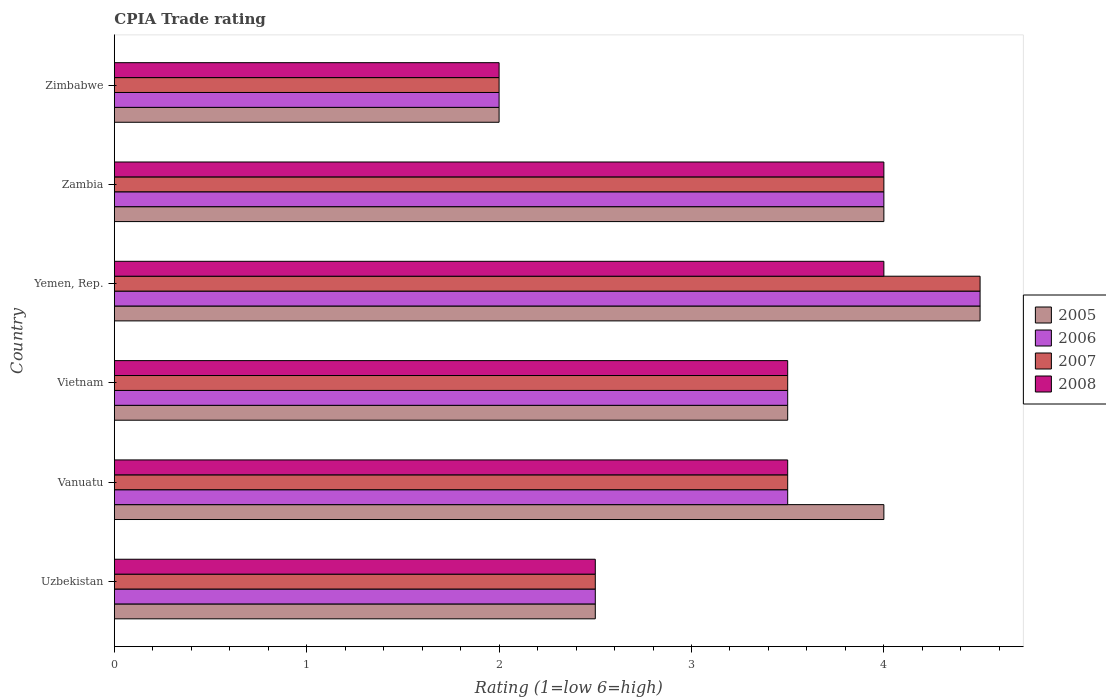How many different coloured bars are there?
Keep it short and to the point. 4. Are the number of bars on each tick of the Y-axis equal?
Offer a terse response. Yes. How many bars are there on the 5th tick from the top?
Give a very brief answer. 4. What is the label of the 2nd group of bars from the top?
Your answer should be very brief. Zambia. Across all countries, what is the minimum CPIA rating in 2008?
Your answer should be very brief. 2. In which country was the CPIA rating in 2007 maximum?
Provide a succinct answer. Yemen, Rep. In which country was the CPIA rating in 2006 minimum?
Provide a short and direct response. Zimbabwe. What is the average CPIA rating in 2006 per country?
Keep it short and to the point. 3.33. What is the difference between the CPIA rating in 2008 and CPIA rating in 2006 in Yemen, Rep.?
Make the answer very short. -0.5. In how many countries, is the CPIA rating in 2005 greater than 2.8 ?
Ensure brevity in your answer.  4. Is the CPIA rating in 2006 in Uzbekistan less than that in Vietnam?
Ensure brevity in your answer.  Yes. What is the difference between the highest and the second highest CPIA rating in 2006?
Your answer should be very brief. 0.5. Is the sum of the CPIA rating in 2005 in Yemen, Rep. and Zambia greater than the maximum CPIA rating in 2008 across all countries?
Make the answer very short. Yes. Is it the case that in every country, the sum of the CPIA rating in 2006 and CPIA rating in 2007 is greater than the sum of CPIA rating in 2008 and CPIA rating in 2005?
Give a very brief answer. No. What does the 3rd bar from the top in Zambia represents?
Your answer should be compact. 2006. Is it the case that in every country, the sum of the CPIA rating in 2007 and CPIA rating in 2006 is greater than the CPIA rating in 2005?
Your response must be concise. Yes. What is the difference between two consecutive major ticks on the X-axis?
Ensure brevity in your answer.  1. Are the values on the major ticks of X-axis written in scientific E-notation?
Keep it short and to the point. No. How many legend labels are there?
Offer a very short reply. 4. What is the title of the graph?
Offer a very short reply. CPIA Trade rating. What is the label or title of the Y-axis?
Provide a succinct answer. Country. What is the Rating (1=low 6=high) of 2006 in Uzbekistan?
Provide a short and direct response. 2.5. What is the Rating (1=low 6=high) of 2008 in Uzbekistan?
Offer a terse response. 2.5. What is the Rating (1=low 6=high) of 2005 in Vanuatu?
Your answer should be compact. 4. What is the Rating (1=low 6=high) of 2006 in Vanuatu?
Keep it short and to the point. 3.5. What is the Rating (1=low 6=high) of 2008 in Vanuatu?
Ensure brevity in your answer.  3.5. What is the Rating (1=low 6=high) in 2005 in Vietnam?
Offer a very short reply. 3.5. What is the Rating (1=low 6=high) in 2006 in Vietnam?
Your answer should be very brief. 3.5. What is the Rating (1=low 6=high) in 2007 in Vietnam?
Ensure brevity in your answer.  3.5. What is the Rating (1=low 6=high) of 2008 in Vietnam?
Keep it short and to the point. 3.5. What is the Rating (1=low 6=high) in 2005 in Yemen, Rep.?
Offer a terse response. 4.5. What is the Rating (1=low 6=high) in 2007 in Yemen, Rep.?
Make the answer very short. 4.5. What is the Rating (1=low 6=high) in 2008 in Yemen, Rep.?
Your response must be concise. 4. What is the Rating (1=low 6=high) of 2005 in Zambia?
Ensure brevity in your answer.  4. What is the Rating (1=low 6=high) in 2006 in Zambia?
Ensure brevity in your answer.  4. What is the Rating (1=low 6=high) of 2008 in Zambia?
Provide a succinct answer. 4. What is the Rating (1=low 6=high) in 2005 in Zimbabwe?
Ensure brevity in your answer.  2. What is the Rating (1=low 6=high) of 2006 in Zimbabwe?
Your answer should be compact. 2. What is the Rating (1=low 6=high) of 2007 in Zimbabwe?
Your answer should be very brief. 2. Across all countries, what is the maximum Rating (1=low 6=high) in 2006?
Your answer should be compact. 4.5. Across all countries, what is the maximum Rating (1=low 6=high) in 2007?
Your answer should be very brief. 4.5. Across all countries, what is the maximum Rating (1=low 6=high) of 2008?
Your response must be concise. 4. Across all countries, what is the minimum Rating (1=low 6=high) of 2006?
Give a very brief answer. 2. What is the total Rating (1=low 6=high) of 2006 in the graph?
Make the answer very short. 20. What is the total Rating (1=low 6=high) of 2008 in the graph?
Provide a succinct answer. 19.5. What is the difference between the Rating (1=low 6=high) of 2005 in Uzbekistan and that in Vanuatu?
Offer a terse response. -1.5. What is the difference between the Rating (1=low 6=high) in 2008 in Uzbekistan and that in Vanuatu?
Offer a very short reply. -1. What is the difference between the Rating (1=low 6=high) in 2006 in Uzbekistan and that in Vietnam?
Give a very brief answer. -1. What is the difference between the Rating (1=low 6=high) in 2008 in Uzbekistan and that in Vietnam?
Your answer should be compact. -1. What is the difference between the Rating (1=low 6=high) of 2007 in Uzbekistan and that in Yemen, Rep.?
Ensure brevity in your answer.  -2. What is the difference between the Rating (1=low 6=high) in 2008 in Uzbekistan and that in Yemen, Rep.?
Make the answer very short. -1.5. What is the difference between the Rating (1=low 6=high) of 2005 in Uzbekistan and that in Zambia?
Your answer should be very brief. -1.5. What is the difference between the Rating (1=low 6=high) in 2007 in Uzbekistan and that in Zambia?
Provide a short and direct response. -1.5. What is the difference between the Rating (1=low 6=high) of 2008 in Uzbekistan and that in Zambia?
Make the answer very short. -1.5. What is the difference between the Rating (1=low 6=high) of 2007 in Uzbekistan and that in Zimbabwe?
Offer a very short reply. 0.5. What is the difference between the Rating (1=low 6=high) in 2008 in Uzbekistan and that in Zimbabwe?
Provide a succinct answer. 0.5. What is the difference between the Rating (1=low 6=high) of 2007 in Vanuatu and that in Vietnam?
Make the answer very short. 0. What is the difference between the Rating (1=low 6=high) in 2005 in Vanuatu and that in Yemen, Rep.?
Provide a short and direct response. -0.5. What is the difference between the Rating (1=low 6=high) of 2008 in Vanuatu and that in Yemen, Rep.?
Keep it short and to the point. -0.5. What is the difference between the Rating (1=low 6=high) in 2005 in Vanuatu and that in Zimbabwe?
Ensure brevity in your answer.  2. What is the difference between the Rating (1=low 6=high) in 2008 in Vanuatu and that in Zimbabwe?
Provide a short and direct response. 1.5. What is the difference between the Rating (1=low 6=high) in 2005 in Vietnam and that in Yemen, Rep.?
Keep it short and to the point. -1. What is the difference between the Rating (1=low 6=high) of 2007 in Vietnam and that in Yemen, Rep.?
Give a very brief answer. -1. What is the difference between the Rating (1=low 6=high) of 2008 in Vietnam and that in Yemen, Rep.?
Provide a succinct answer. -0.5. What is the difference between the Rating (1=low 6=high) of 2005 in Vietnam and that in Zambia?
Ensure brevity in your answer.  -0.5. What is the difference between the Rating (1=low 6=high) of 2006 in Vietnam and that in Zambia?
Provide a succinct answer. -0.5. What is the difference between the Rating (1=low 6=high) of 2007 in Vietnam and that in Zimbabwe?
Offer a terse response. 1.5. What is the difference between the Rating (1=low 6=high) in 2005 in Yemen, Rep. and that in Zambia?
Your response must be concise. 0.5. What is the difference between the Rating (1=low 6=high) of 2006 in Yemen, Rep. and that in Zambia?
Give a very brief answer. 0.5. What is the difference between the Rating (1=low 6=high) in 2007 in Yemen, Rep. and that in Zambia?
Provide a short and direct response. 0.5. What is the difference between the Rating (1=low 6=high) in 2005 in Yemen, Rep. and that in Zimbabwe?
Offer a very short reply. 2.5. What is the difference between the Rating (1=low 6=high) of 2007 in Zambia and that in Zimbabwe?
Make the answer very short. 2. What is the difference between the Rating (1=low 6=high) of 2008 in Zambia and that in Zimbabwe?
Ensure brevity in your answer.  2. What is the difference between the Rating (1=low 6=high) in 2005 in Uzbekistan and the Rating (1=low 6=high) in 2006 in Vanuatu?
Offer a very short reply. -1. What is the difference between the Rating (1=low 6=high) of 2005 in Uzbekistan and the Rating (1=low 6=high) of 2007 in Vanuatu?
Ensure brevity in your answer.  -1. What is the difference between the Rating (1=low 6=high) of 2005 in Uzbekistan and the Rating (1=low 6=high) of 2008 in Vietnam?
Offer a very short reply. -1. What is the difference between the Rating (1=low 6=high) of 2007 in Uzbekistan and the Rating (1=low 6=high) of 2008 in Vietnam?
Give a very brief answer. -1. What is the difference between the Rating (1=low 6=high) in 2005 in Uzbekistan and the Rating (1=low 6=high) in 2006 in Yemen, Rep.?
Give a very brief answer. -2. What is the difference between the Rating (1=low 6=high) in 2005 in Uzbekistan and the Rating (1=low 6=high) in 2007 in Yemen, Rep.?
Your response must be concise. -2. What is the difference between the Rating (1=low 6=high) of 2006 in Uzbekistan and the Rating (1=low 6=high) of 2007 in Yemen, Rep.?
Offer a terse response. -2. What is the difference between the Rating (1=low 6=high) in 2006 in Uzbekistan and the Rating (1=low 6=high) in 2008 in Yemen, Rep.?
Your response must be concise. -1.5. What is the difference between the Rating (1=low 6=high) of 2006 in Uzbekistan and the Rating (1=low 6=high) of 2007 in Zambia?
Give a very brief answer. -1.5. What is the difference between the Rating (1=low 6=high) of 2007 in Uzbekistan and the Rating (1=low 6=high) of 2008 in Zambia?
Your answer should be very brief. -1.5. What is the difference between the Rating (1=low 6=high) of 2005 in Uzbekistan and the Rating (1=low 6=high) of 2007 in Zimbabwe?
Provide a short and direct response. 0.5. What is the difference between the Rating (1=low 6=high) in 2007 in Uzbekistan and the Rating (1=low 6=high) in 2008 in Zimbabwe?
Offer a very short reply. 0.5. What is the difference between the Rating (1=low 6=high) of 2005 in Vanuatu and the Rating (1=low 6=high) of 2007 in Vietnam?
Offer a terse response. 0.5. What is the difference between the Rating (1=low 6=high) in 2006 in Vanuatu and the Rating (1=low 6=high) in 2007 in Vietnam?
Keep it short and to the point. 0. What is the difference between the Rating (1=low 6=high) in 2006 in Vanuatu and the Rating (1=low 6=high) in 2008 in Vietnam?
Give a very brief answer. 0. What is the difference between the Rating (1=low 6=high) of 2005 in Vanuatu and the Rating (1=low 6=high) of 2008 in Yemen, Rep.?
Keep it short and to the point. 0. What is the difference between the Rating (1=low 6=high) in 2007 in Vanuatu and the Rating (1=low 6=high) in 2008 in Yemen, Rep.?
Your response must be concise. -0.5. What is the difference between the Rating (1=low 6=high) in 2006 in Vanuatu and the Rating (1=low 6=high) in 2007 in Zambia?
Provide a short and direct response. -0.5. What is the difference between the Rating (1=low 6=high) of 2006 in Vanuatu and the Rating (1=low 6=high) of 2008 in Zambia?
Ensure brevity in your answer.  -0.5. What is the difference between the Rating (1=low 6=high) of 2007 in Vanuatu and the Rating (1=low 6=high) of 2008 in Zambia?
Ensure brevity in your answer.  -0.5. What is the difference between the Rating (1=low 6=high) of 2006 in Vanuatu and the Rating (1=low 6=high) of 2007 in Zimbabwe?
Give a very brief answer. 1.5. What is the difference between the Rating (1=low 6=high) of 2005 in Vietnam and the Rating (1=low 6=high) of 2008 in Yemen, Rep.?
Make the answer very short. -0.5. What is the difference between the Rating (1=low 6=high) in 2006 in Vietnam and the Rating (1=low 6=high) in 2008 in Yemen, Rep.?
Your answer should be compact. -0.5. What is the difference between the Rating (1=low 6=high) of 2005 in Vietnam and the Rating (1=low 6=high) of 2006 in Zambia?
Offer a very short reply. -0.5. What is the difference between the Rating (1=low 6=high) in 2006 in Vietnam and the Rating (1=low 6=high) in 2007 in Zambia?
Give a very brief answer. -0.5. What is the difference between the Rating (1=low 6=high) of 2006 in Vietnam and the Rating (1=low 6=high) of 2008 in Zambia?
Make the answer very short. -0.5. What is the difference between the Rating (1=low 6=high) in 2005 in Vietnam and the Rating (1=low 6=high) in 2006 in Zimbabwe?
Your response must be concise. 1.5. What is the difference between the Rating (1=low 6=high) in 2005 in Vietnam and the Rating (1=low 6=high) in 2007 in Zimbabwe?
Offer a very short reply. 1.5. What is the difference between the Rating (1=low 6=high) in 2006 in Vietnam and the Rating (1=low 6=high) in 2007 in Zimbabwe?
Offer a very short reply. 1.5. What is the difference between the Rating (1=low 6=high) in 2006 in Vietnam and the Rating (1=low 6=high) in 2008 in Zimbabwe?
Offer a terse response. 1.5. What is the difference between the Rating (1=low 6=high) in 2007 in Vietnam and the Rating (1=low 6=high) in 2008 in Zimbabwe?
Your answer should be compact. 1.5. What is the difference between the Rating (1=low 6=high) of 2005 in Yemen, Rep. and the Rating (1=low 6=high) of 2006 in Zambia?
Your answer should be compact. 0.5. What is the difference between the Rating (1=low 6=high) in 2006 in Yemen, Rep. and the Rating (1=low 6=high) in 2007 in Zambia?
Your answer should be very brief. 0.5. What is the difference between the Rating (1=low 6=high) of 2006 in Yemen, Rep. and the Rating (1=low 6=high) of 2008 in Zambia?
Give a very brief answer. 0.5. What is the difference between the Rating (1=low 6=high) of 2006 in Yemen, Rep. and the Rating (1=low 6=high) of 2007 in Zimbabwe?
Offer a very short reply. 2.5. What is the difference between the Rating (1=low 6=high) in 2005 in Zambia and the Rating (1=low 6=high) in 2007 in Zimbabwe?
Your response must be concise. 2. What is the difference between the Rating (1=low 6=high) of 2006 in Zambia and the Rating (1=low 6=high) of 2007 in Zimbabwe?
Give a very brief answer. 2. What is the difference between the Rating (1=low 6=high) of 2007 in Zambia and the Rating (1=low 6=high) of 2008 in Zimbabwe?
Ensure brevity in your answer.  2. What is the average Rating (1=low 6=high) in 2005 per country?
Your answer should be very brief. 3.42. What is the average Rating (1=low 6=high) of 2006 per country?
Make the answer very short. 3.33. What is the average Rating (1=low 6=high) of 2008 per country?
Make the answer very short. 3.25. What is the difference between the Rating (1=low 6=high) in 2005 and Rating (1=low 6=high) in 2006 in Uzbekistan?
Offer a terse response. 0. What is the difference between the Rating (1=low 6=high) of 2005 and Rating (1=low 6=high) of 2008 in Uzbekistan?
Your answer should be compact. 0. What is the difference between the Rating (1=low 6=high) in 2005 and Rating (1=low 6=high) in 2006 in Vanuatu?
Your response must be concise. 0.5. What is the difference between the Rating (1=low 6=high) of 2005 and Rating (1=low 6=high) of 2008 in Vanuatu?
Your answer should be compact. 0.5. What is the difference between the Rating (1=low 6=high) in 2006 and Rating (1=low 6=high) in 2007 in Vanuatu?
Ensure brevity in your answer.  0. What is the difference between the Rating (1=low 6=high) of 2006 and Rating (1=low 6=high) of 2008 in Vanuatu?
Provide a short and direct response. 0. What is the difference between the Rating (1=low 6=high) of 2005 and Rating (1=low 6=high) of 2006 in Vietnam?
Provide a short and direct response. 0. What is the difference between the Rating (1=low 6=high) in 2005 and Rating (1=low 6=high) in 2008 in Vietnam?
Ensure brevity in your answer.  0. What is the difference between the Rating (1=low 6=high) of 2006 and Rating (1=low 6=high) of 2007 in Vietnam?
Your answer should be compact. 0. What is the difference between the Rating (1=low 6=high) in 2006 and Rating (1=low 6=high) in 2008 in Vietnam?
Your answer should be very brief. 0. What is the difference between the Rating (1=low 6=high) in 2005 and Rating (1=low 6=high) in 2008 in Yemen, Rep.?
Provide a short and direct response. 0.5. What is the difference between the Rating (1=low 6=high) of 2006 and Rating (1=low 6=high) of 2008 in Yemen, Rep.?
Your response must be concise. 0.5. What is the difference between the Rating (1=low 6=high) of 2007 and Rating (1=low 6=high) of 2008 in Yemen, Rep.?
Provide a short and direct response. 0.5. What is the difference between the Rating (1=low 6=high) in 2005 and Rating (1=low 6=high) in 2006 in Zambia?
Your answer should be very brief. 0. What is the difference between the Rating (1=low 6=high) in 2006 and Rating (1=low 6=high) in 2007 in Zambia?
Give a very brief answer. 0. What is the difference between the Rating (1=low 6=high) in 2006 and Rating (1=low 6=high) in 2008 in Zambia?
Offer a very short reply. 0. What is the difference between the Rating (1=low 6=high) of 2007 and Rating (1=low 6=high) of 2008 in Zambia?
Provide a succinct answer. 0. What is the difference between the Rating (1=low 6=high) in 2005 and Rating (1=low 6=high) in 2006 in Zimbabwe?
Provide a short and direct response. 0. What is the difference between the Rating (1=low 6=high) in 2005 and Rating (1=low 6=high) in 2008 in Zimbabwe?
Offer a terse response. 0. What is the difference between the Rating (1=low 6=high) in 2006 and Rating (1=low 6=high) in 2007 in Zimbabwe?
Provide a short and direct response. 0. What is the difference between the Rating (1=low 6=high) of 2007 and Rating (1=low 6=high) of 2008 in Zimbabwe?
Ensure brevity in your answer.  0. What is the ratio of the Rating (1=low 6=high) of 2006 in Uzbekistan to that in Vanuatu?
Your answer should be very brief. 0.71. What is the ratio of the Rating (1=low 6=high) of 2007 in Uzbekistan to that in Vanuatu?
Provide a succinct answer. 0.71. What is the ratio of the Rating (1=low 6=high) in 2005 in Uzbekistan to that in Vietnam?
Keep it short and to the point. 0.71. What is the ratio of the Rating (1=low 6=high) in 2007 in Uzbekistan to that in Vietnam?
Make the answer very short. 0.71. What is the ratio of the Rating (1=low 6=high) in 2008 in Uzbekistan to that in Vietnam?
Offer a terse response. 0.71. What is the ratio of the Rating (1=low 6=high) in 2005 in Uzbekistan to that in Yemen, Rep.?
Offer a very short reply. 0.56. What is the ratio of the Rating (1=low 6=high) in 2006 in Uzbekistan to that in Yemen, Rep.?
Your response must be concise. 0.56. What is the ratio of the Rating (1=low 6=high) in 2007 in Uzbekistan to that in Yemen, Rep.?
Keep it short and to the point. 0.56. What is the ratio of the Rating (1=low 6=high) in 2008 in Uzbekistan to that in Yemen, Rep.?
Provide a succinct answer. 0.62. What is the ratio of the Rating (1=low 6=high) in 2005 in Uzbekistan to that in Zambia?
Provide a succinct answer. 0.62. What is the ratio of the Rating (1=low 6=high) of 2008 in Uzbekistan to that in Zambia?
Your response must be concise. 0.62. What is the ratio of the Rating (1=low 6=high) in 2006 in Uzbekistan to that in Zimbabwe?
Give a very brief answer. 1.25. What is the ratio of the Rating (1=low 6=high) in 2006 in Vanuatu to that in Vietnam?
Your answer should be compact. 1. What is the ratio of the Rating (1=low 6=high) of 2007 in Vanuatu to that in Vietnam?
Provide a succinct answer. 1. What is the ratio of the Rating (1=low 6=high) of 2008 in Vanuatu to that in Vietnam?
Your answer should be compact. 1. What is the ratio of the Rating (1=low 6=high) of 2005 in Vanuatu to that in Yemen, Rep.?
Provide a succinct answer. 0.89. What is the ratio of the Rating (1=low 6=high) in 2006 in Vanuatu to that in Yemen, Rep.?
Keep it short and to the point. 0.78. What is the ratio of the Rating (1=low 6=high) of 2008 in Vanuatu to that in Yemen, Rep.?
Your answer should be very brief. 0.88. What is the ratio of the Rating (1=low 6=high) of 2005 in Vanuatu to that in Zambia?
Give a very brief answer. 1. What is the ratio of the Rating (1=low 6=high) in 2006 in Vanuatu to that in Zambia?
Give a very brief answer. 0.88. What is the ratio of the Rating (1=low 6=high) in 2007 in Vanuatu to that in Zambia?
Offer a very short reply. 0.88. What is the ratio of the Rating (1=low 6=high) of 2008 in Vanuatu to that in Zimbabwe?
Your answer should be compact. 1.75. What is the ratio of the Rating (1=low 6=high) in 2005 in Vietnam to that in Yemen, Rep.?
Give a very brief answer. 0.78. What is the ratio of the Rating (1=low 6=high) in 2006 in Vietnam to that in Yemen, Rep.?
Your answer should be compact. 0.78. What is the ratio of the Rating (1=low 6=high) of 2007 in Vietnam to that in Zambia?
Keep it short and to the point. 0.88. What is the ratio of the Rating (1=low 6=high) in 2007 in Vietnam to that in Zimbabwe?
Provide a short and direct response. 1.75. What is the ratio of the Rating (1=low 6=high) of 2008 in Vietnam to that in Zimbabwe?
Offer a very short reply. 1.75. What is the ratio of the Rating (1=low 6=high) in 2005 in Yemen, Rep. to that in Zambia?
Provide a short and direct response. 1.12. What is the ratio of the Rating (1=low 6=high) in 2005 in Yemen, Rep. to that in Zimbabwe?
Provide a succinct answer. 2.25. What is the ratio of the Rating (1=low 6=high) of 2006 in Yemen, Rep. to that in Zimbabwe?
Your answer should be compact. 2.25. What is the ratio of the Rating (1=low 6=high) in 2007 in Yemen, Rep. to that in Zimbabwe?
Provide a succinct answer. 2.25. What is the difference between the highest and the second highest Rating (1=low 6=high) of 2005?
Offer a terse response. 0.5. What is the difference between the highest and the second highest Rating (1=low 6=high) of 2007?
Your response must be concise. 0.5. What is the difference between the highest and the second highest Rating (1=low 6=high) of 2008?
Provide a succinct answer. 0. What is the difference between the highest and the lowest Rating (1=low 6=high) in 2006?
Your response must be concise. 2.5. What is the difference between the highest and the lowest Rating (1=low 6=high) in 2007?
Your response must be concise. 2.5. 